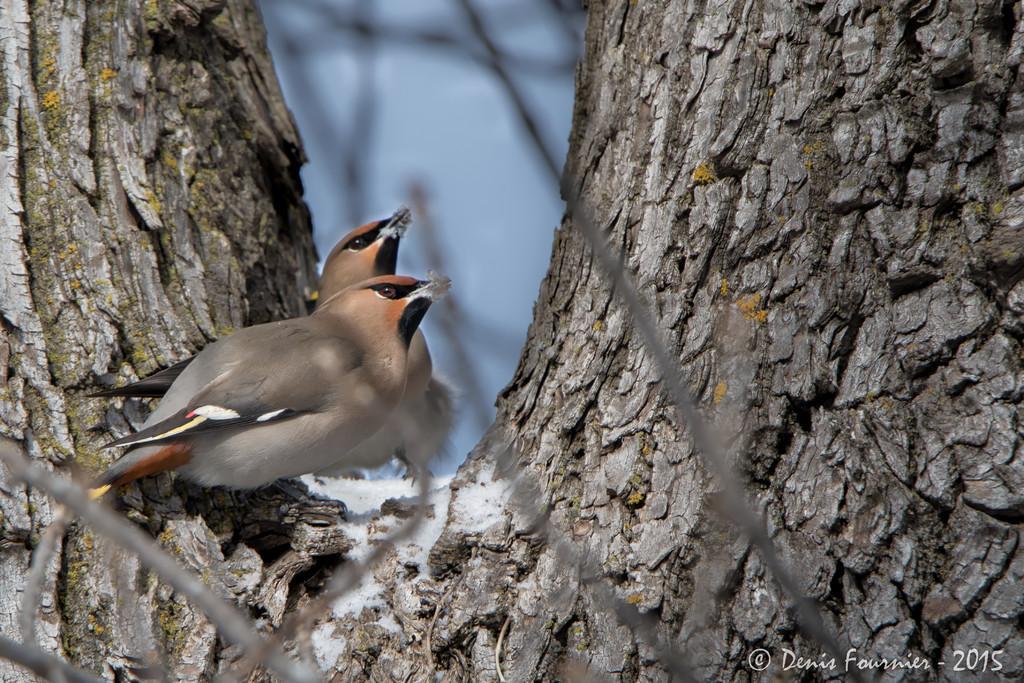Can you describe this image briefly? This image is taken outdoors. In the background there is a ground covered with snow. In the middle of the image there is a tree and there are two birds on the branch of a tree. They are grey and orange in colour. 